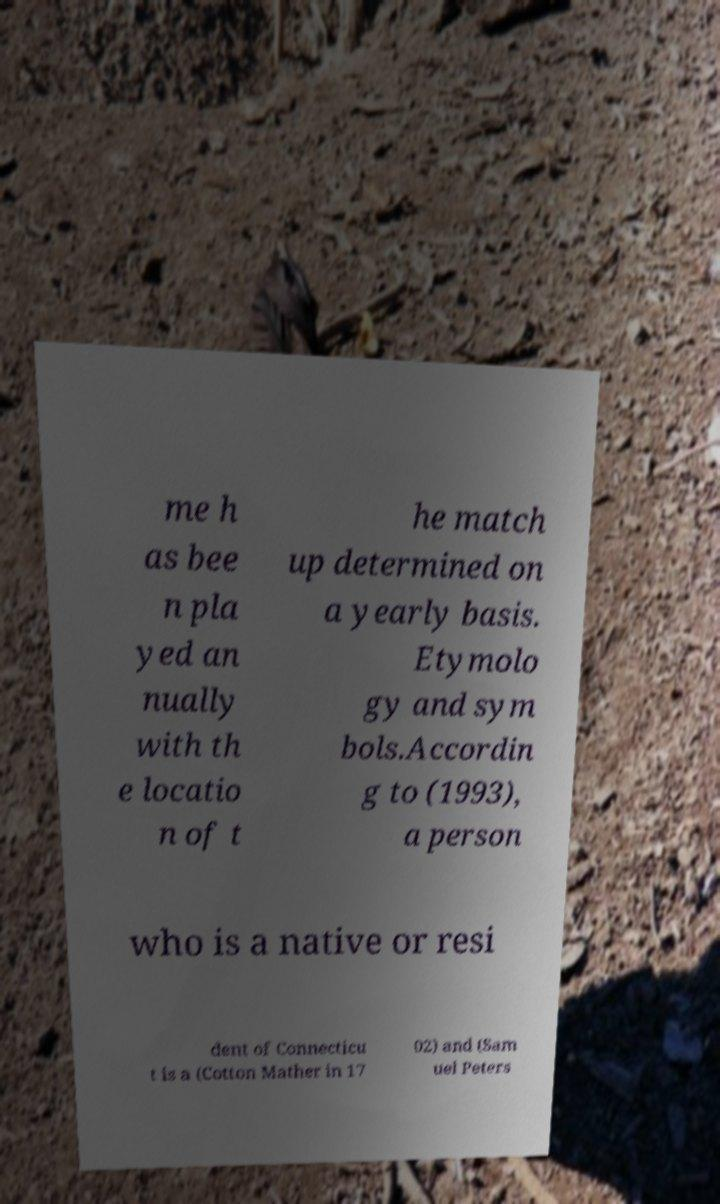Please read and relay the text visible in this image. What does it say? me h as bee n pla yed an nually with th e locatio n of t he match up determined on a yearly basis. Etymolo gy and sym bols.Accordin g to (1993), a person who is a native or resi dent of Connecticu t is a (Cotton Mather in 17 02) and (Sam uel Peters 